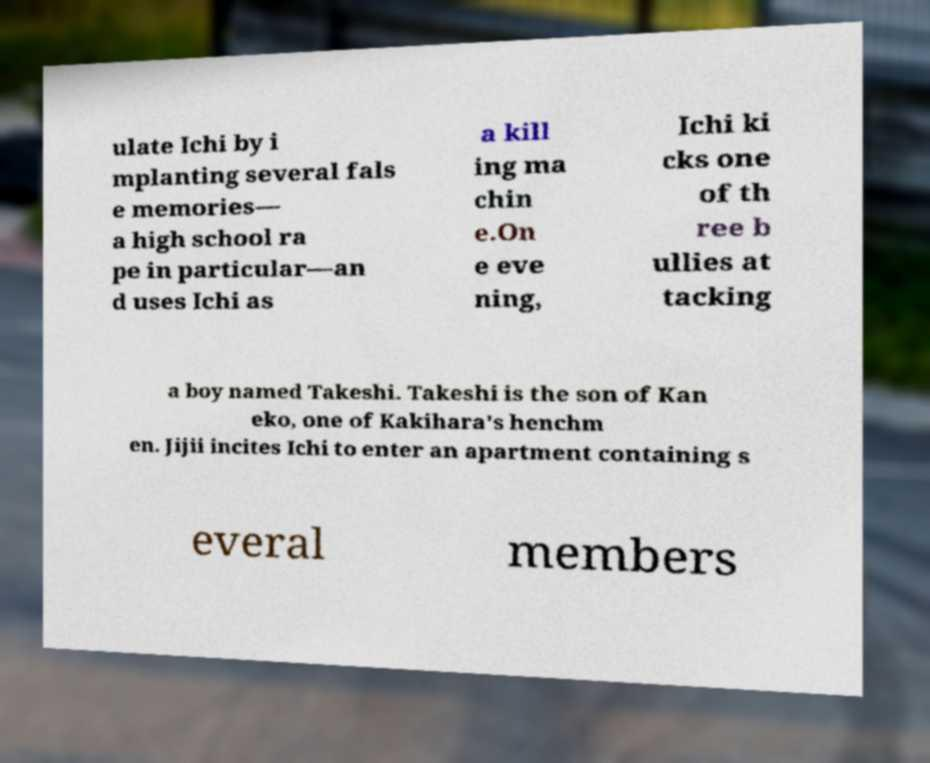Can you read and provide the text displayed in the image?This photo seems to have some interesting text. Can you extract and type it out for me? ulate Ichi by i mplanting several fals e memories— a high school ra pe in particular—an d uses Ichi as a kill ing ma chin e.On e eve ning, Ichi ki cks one of th ree b ullies at tacking a boy named Takeshi. Takeshi is the son of Kan eko, one of Kakihara's henchm en. Jijii incites Ichi to enter an apartment containing s everal members 